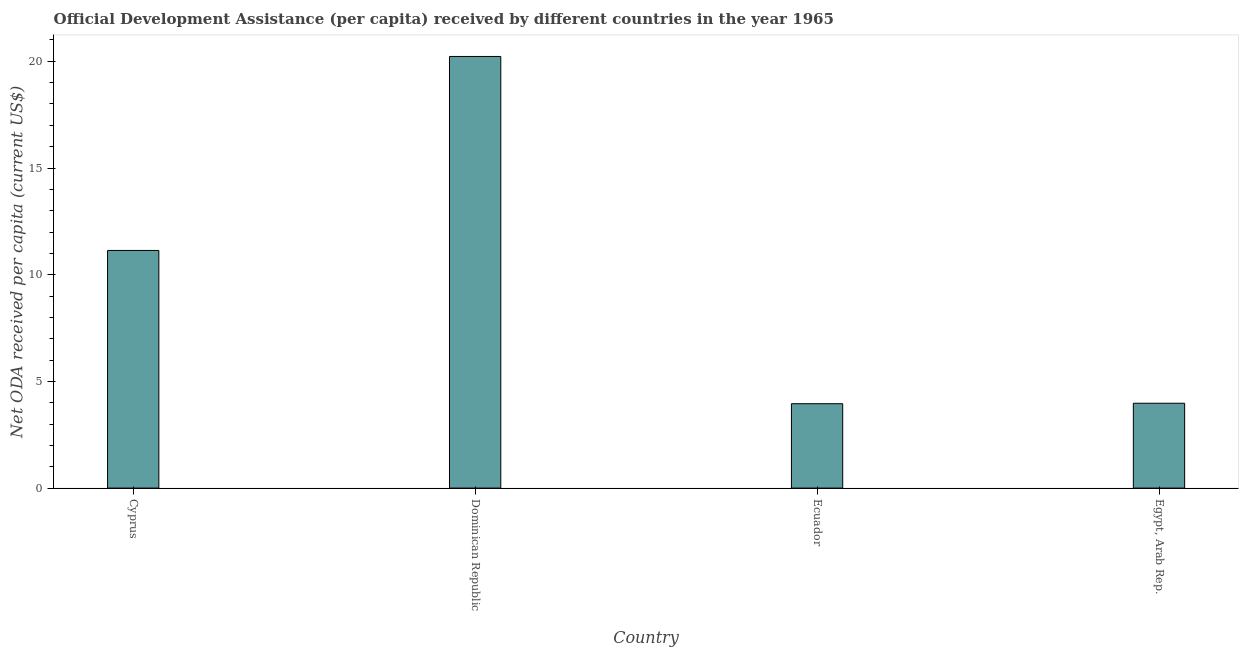Does the graph contain grids?
Offer a terse response. No. What is the title of the graph?
Offer a very short reply. Official Development Assistance (per capita) received by different countries in the year 1965. What is the label or title of the X-axis?
Your answer should be very brief. Country. What is the label or title of the Y-axis?
Ensure brevity in your answer.  Net ODA received per capita (current US$). What is the net oda received per capita in Ecuador?
Provide a short and direct response. 3.95. Across all countries, what is the maximum net oda received per capita?
Offer a terse response. 20.23. Across all countries, what is the minimum net oda received per capita?
Your answer should be compact. 3.95. In which country was the net oda received per capita maximum?
Your answer should be very brief. Dominican Republic. In which country was the net oda received per capita minimum?
Provide a short and direct response. Ecuador. What is the sum of the net oda received per capita?
Offer a very short reply. 39.29. What is the difference between the net oda received per capita in Cyprus and Ecuador?
Offer a terse response. 7.18. What is the average net oda received per capita per country?
Ensure brevity in your answer.  9.82. What is the median net oda received per capita?
Keep it short and to the point. 7.56. In how many countries, is the net oda received per capita greater than 7 US$?
Provide a succinct answer. 2. What is the ratio of the net oda received per capita in Dominican Republic to that in Egypt, Arab Rep.?
Offer a very short reply. 5.09. Is the difference between the net oda received per capita in Ecuador and Egypt, Arab Rep. greater than the difference between any two countries?
Keep it short and to the point. No. What is the difference between the highest and the second highest net oda received per capita?
Keep it short and to the point. 9.09. What is the difference between the highest and the lowest net oda received per capita?
Offer a very short reply. 16.27. In how many countries, is the net oda received per capita greater than the average net oda received per capita taken over all countries?
Your response must be concise. 2. How many bars are there?
Your answer should be very brief. 4. How many countries are there in the graph?
Provide a short and direct response. 4. What is the Net ODA received per capita (current US$) in Cyprus?
Keep it short and to the point. 11.14. What is the Net ODA received per capita (current US$) of Dominican Republic?
Ensure brevity in your answer.  20.23. What is the Net ODA received per capita (current US$) of Ecuador?
Offer a terse response. 3.95. What is the Net ODA received per capita (current US$) in Egypt, Arab Rep.?
Give a very brief answer. 3.98. What is the difference between the Net ODA received per capita (current US$) in Cyprus and Dominican Republic?
Your answer should be very brief. -9.09. What is the difference between the Net ODA received per capita (current US$) in Cyprus and Ecuador?
Keep it short and to the point. 7.18. What is the difference between the Net ODA received per capita (current US$) in Cyprus and Egypt, Arab Rep.?
Provide a short and direct response. 7.16. What is the difference between the Net ODA received per capita (current US$) in Dominican Republic and Ecuador?
Your answer should be very brief. 16.27. What is the difference between the Net ODA received per capita (current US$) in Dominican Republic and Egypt, Arab Rep.?
Ensure brevity in your answer.  16.25. What is the difference between the Net ODA received per capita (current US$) in Ecuador and Egypt, Arab Rep.?
Offer a terse response. -0.02. What is the ratio of the Net ODA received per capita (current US$) in Cyprus to that in Dominican Republic?
Provide a succinct answer. 0.55. What is the ratio of the Net ODA received per capita (current US$) in Cyprus to that in Ecuador?
Your response must be concise. 2.82. What is the ratio of the Net ODA received per capita (current US$) in Cyprus to that in Egypt, Arab Rep.?
Keep it short and to the point. 2.8. What is the ratio of the Net ODA received per capita (current US$) in Dominican Republic to that in Ecuador?
Ensure brevity in your answer.  5.12. What is the ratio of the Net ODA received per capita (current US$) in Dominican Republic to that in Egypt, Arab Rep.?
Offer a terse response. 5.09. What is the ratio of the Net ODA received per capita (current US$) in Ecuador to that in Egypt, Arab Rep.?
Ensure brevity in your answer.  0.99. 